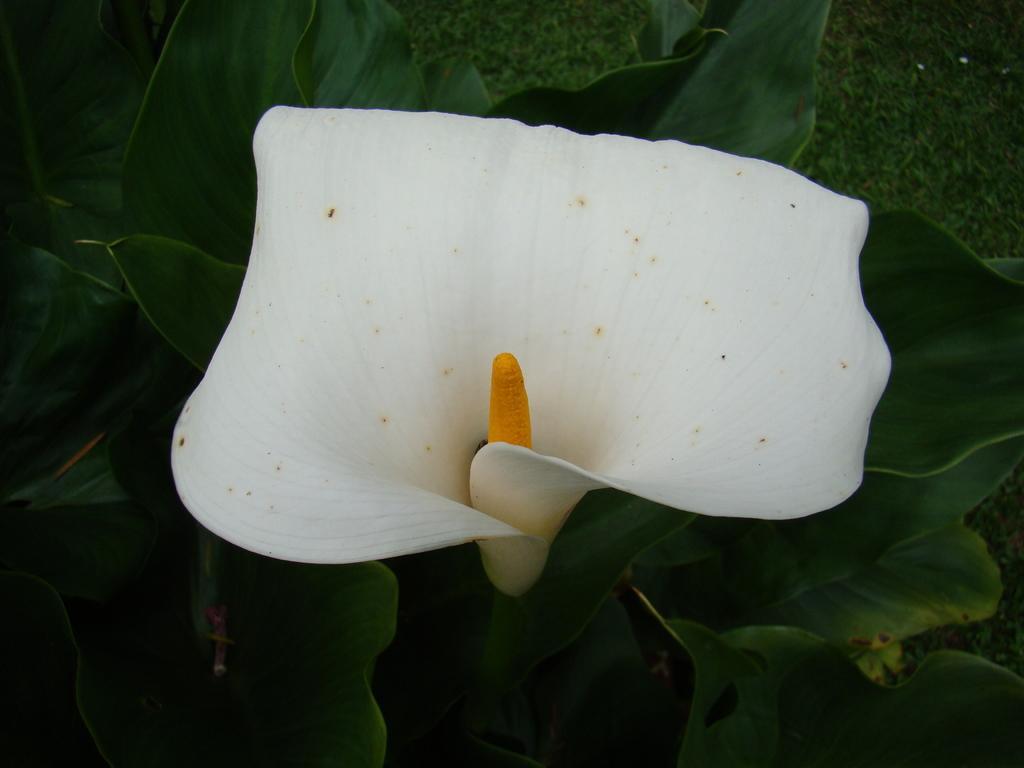Please provide a concise description of this image. In this image there is a flower, behind the flower there are leaves. 